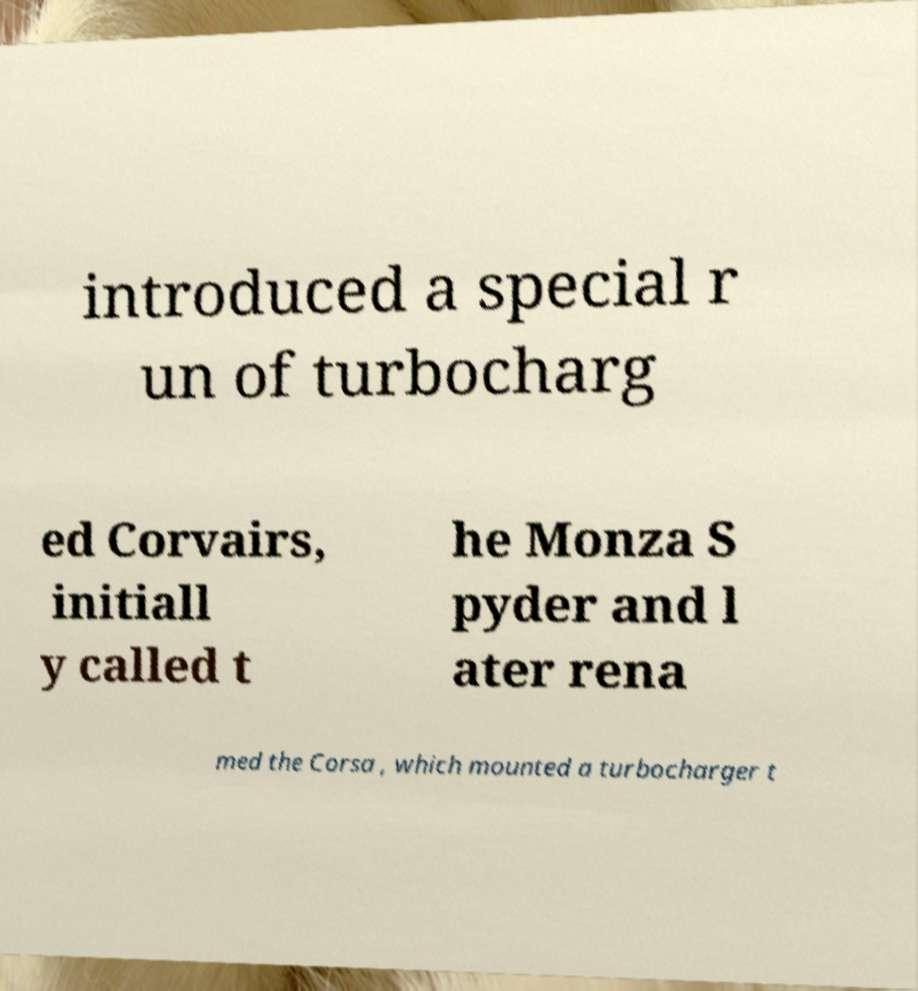Can you read and provide the text displayed in the image?This photo seems to have some interesting text. Can you extract and type it out for me? introduced a special r un of turbocharg ed Corvairs, initiall y called t he Monza S pyder and l ater rena med the Corsa , which mounted a turbocharger t 